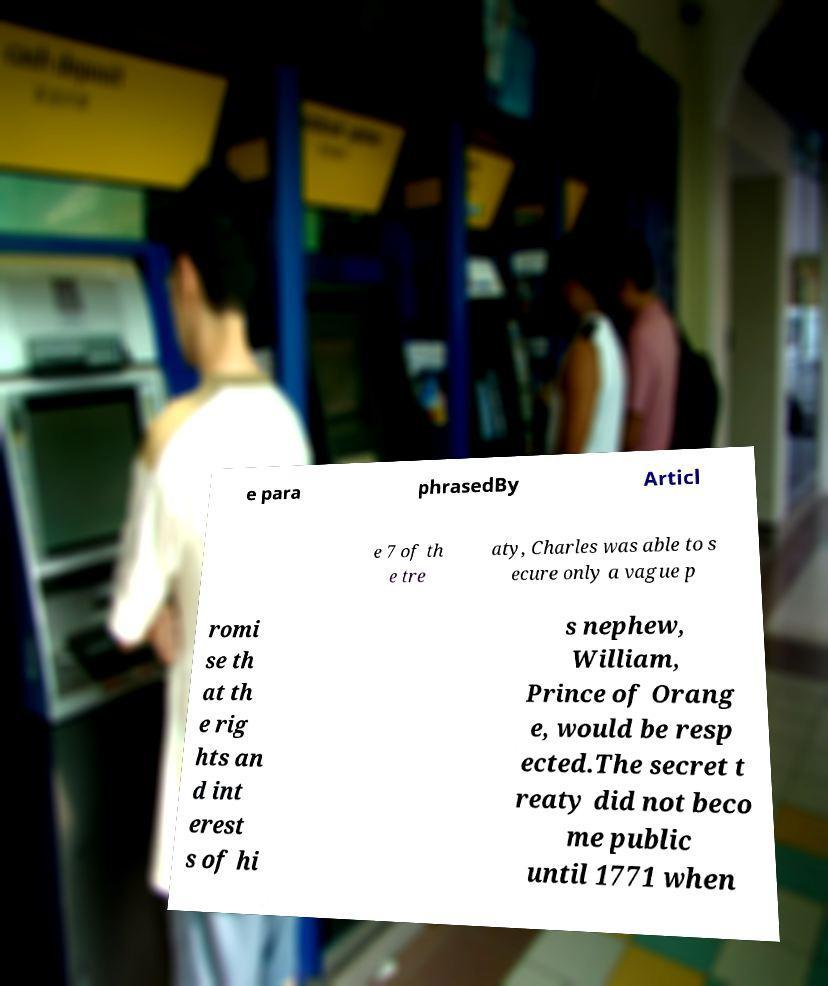I need the written content from this picture converted into text. Can you do that? e para phrasedBy Articl e 7 of th e tre aty, Charles was able to s ecure only a vague p romi se th at th e rig hts an d int erest s of hi s nephew, William, Prince of Orang e, would be resp ected.The secret t reaty did not beco me public until 1771 when 